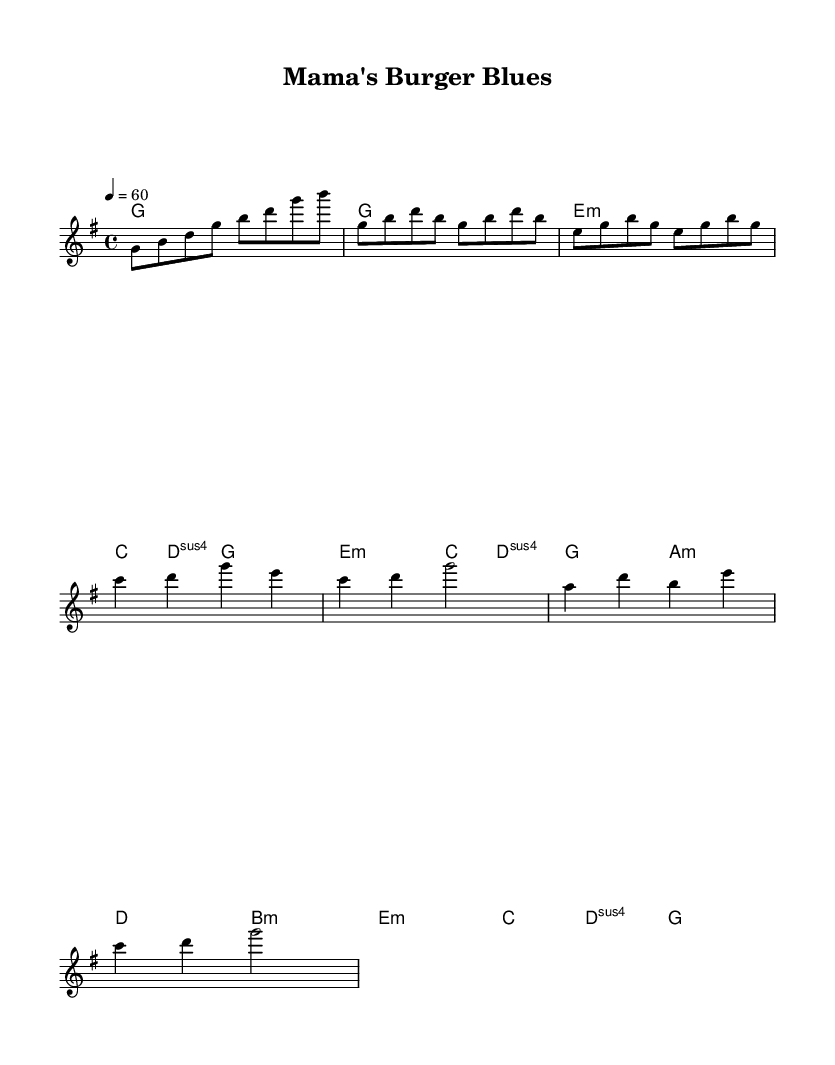What is the key signature of this music? The key signature is G major, which has one sharp (F#). You can tell by looking at the beginning of the staff where the sharp is placed.
Answer: G major What is the time signature of this piece? The time signature is 4/4, indicated at the beginning of the music. This means there are four beats in each measure and the quarter note gets one beat.
Answer: 4/4 What is the tempo marking of this score? The tempo marking is 60 beats per minute, which is indicated at the beginning of the score. This tells the performer how fast to play the piece.
Answer: 60 Which chord follows the chorus? The chord following the chorus is E minor. To find this, look at the chord symbols above the melody after the chorus section is finished.
Answer: E minor How many measures are there in the verse? There are four measures in the verse, as indicated by the grouping of notes and the alignment of the lyrics. Each measure contains a certain number of beats that fit within the 4/4 time signature.
Answer: 4 What is the mood conveyed in the lyrics? The mood conveyed in the lyrics is nostalgic, as the singer reflects on fond memories associated with childhood food experiences. This is inferred from the emotional content of the lyrics.
Answer: Nostalgic What type of song structure is used in this piece? The song structure used in this piece is verse-chorus form. You can identify this by the alternating sections of lyrics and the repetition of the chorus after the verses.
Answer: Verse-chorus 